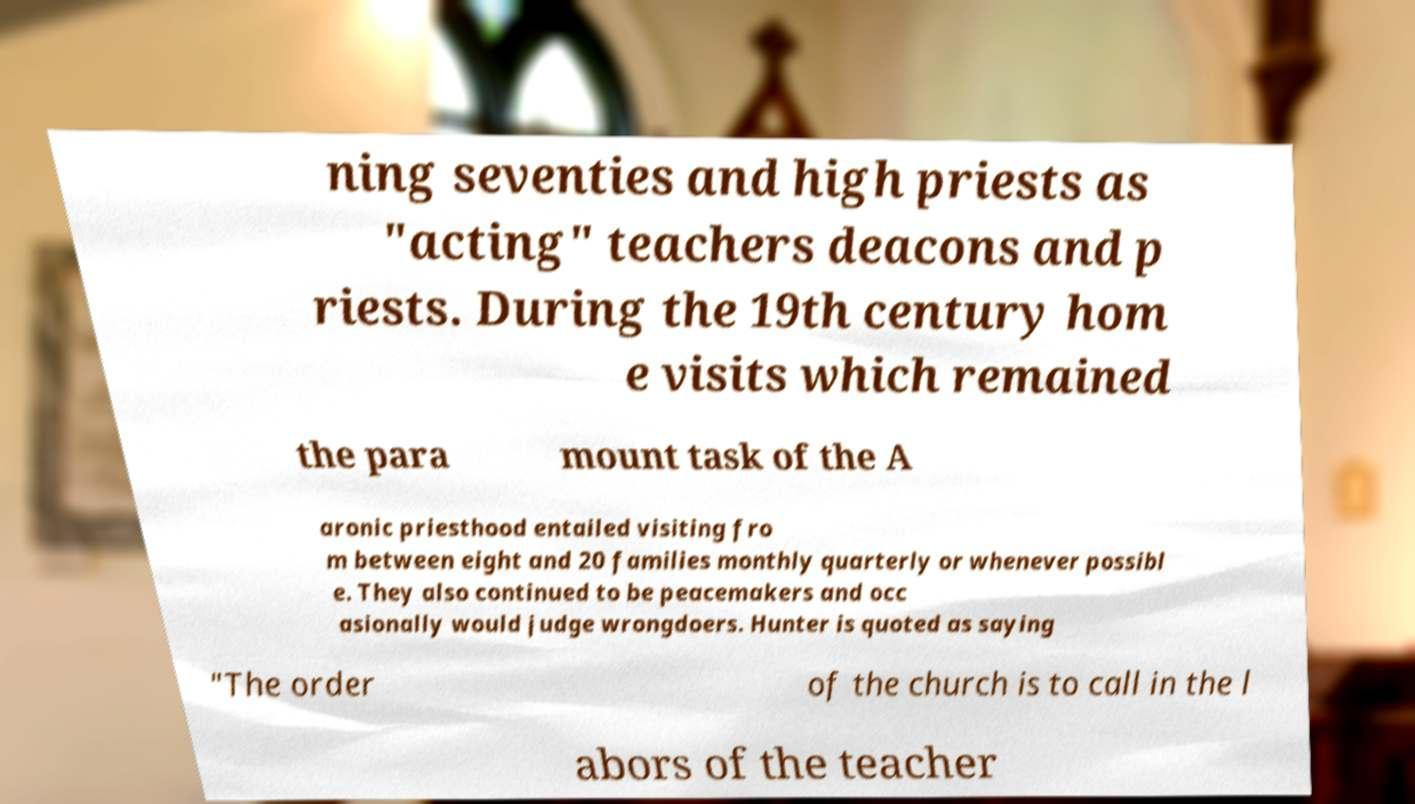Could you assist in decoding the text presented in this image and type it out clearly? ning seventies and high priests as "acting" teachers deacons and p riests. During the 19th century hom e visits which remained the para mount task of the A aronic priesthood entailed visiting fro m between eight and 20 families monthly quarterly or whenever possibl e. They also continued to be peacemakers and occ asionally would judge wrongdoers. Hunter is quoted as saying "The order of the church is to call in the l abors of the teacher 